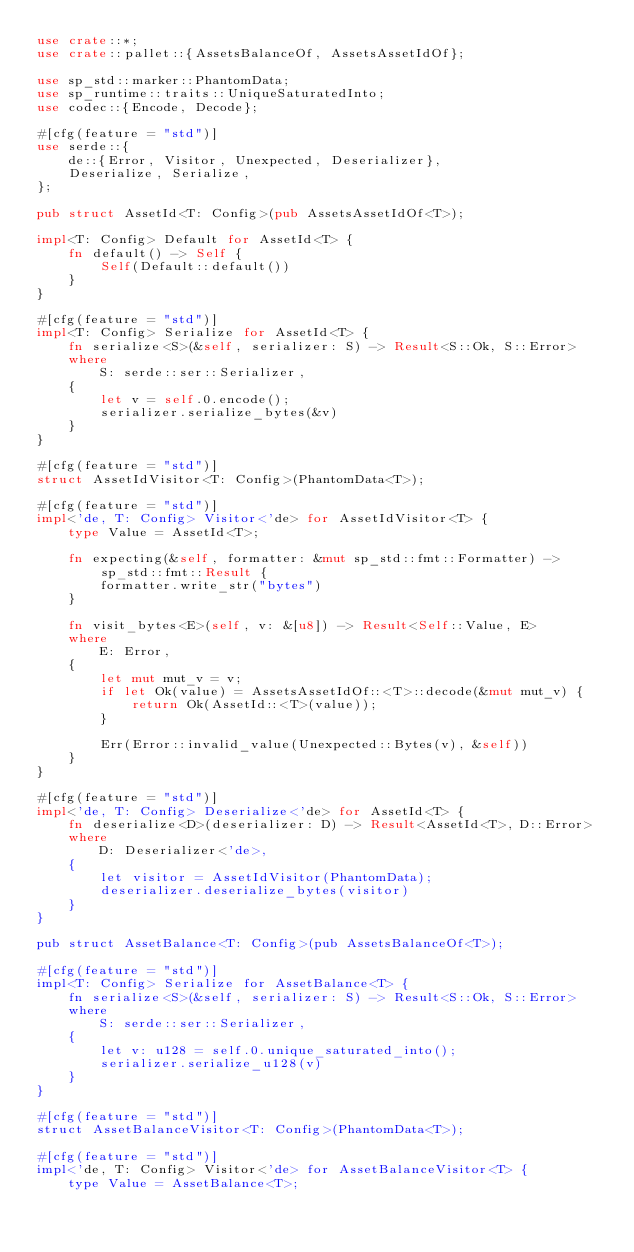<code> <loc_0><loc_0><loc_500><loc_500><_Rust_>use crate::*;
use crate::pallet::{AssetsBalanceOf, AssetsAssetIdOf};

use sp_std::marker::PhantomData;
use sp_runtime::traits::UniqueSaturatedInto;
use codec::{Encode, Decode};

#[cfg(feature = "std")]
use serde::{
    de::{Error, Visitor, Unexpected, Deserializer},
    Deserialize, Serialize,
};

pub struct AssetId<T: Config>(pub AssetsAssetIdOf<T>);

impl<T: Config> Default for AssetId<T> {
    fn default() -> Self {
        Self(Default::default())
    }
}

#[cfg(feature = "std")]
impl<T: Config> Serialize for AssetId<T> {
    fn serialize<S>(&self, serializer: S) -> Result<S::Ok, S::Error>
    where
        S: serde::ser::Serializer,
    {
        let v = self.0.encode();
        serializer.serialize_bytes(&v)
    }
}

#[cfg(feature = "std")]
struct AssetIdVisitor<T: Config>(PhantomData<T>);

#[cfg(feature = "std")]
impl<'de, T: Config> Visitor<'de> for AssetIdVisitor<T> {
    type Value = AssetId<T>;

    fn expecting(&self, formatter: &mut sp_std::fmt::Formatter) -> sp_std::fmt::Result {
        formatter.write_str("bytes")
    }

    fn visit_bytes<E>(self, v: &[u8]) -> Result<Self::Value, E>
    where
        E: Error,
    {
        let mut mut_v = v;
        if let Ok(value) = AssetsAssetIdOf::<T>::decode(&mut mut_v) {
            return Ok(AssetId::<T>(value));
        }

        Err(Error::invalid_value(Unexpected::Bytes(v), &self))
    }
}

#[cfg(feature = "std")]
impl<'de, T: Config> Deserialize<'de> for AssetId<T> {
    fn deserialize<D>(deserializer: D) -> Result<AssetId<T>, D::Error>
    where
        D: Deserializer<'de>,
    {
        let visitor = AssetIdVisitor(PhantomData);
        deserializer.deserialize_bytes(visitor)
    }
}

pub struct AssetBalance<T: Config>(pub AssetsBalanceOf<T>);

#[cfg(feature = "std")]
impl<T: Config> Serialize for AssetBalance<T> {
    fn serialize<S>(&self, serializer: S) -> Result<S::Ok, S::Error>
    where
        S: serde::ser::Serializer,
    {
        let v: u128 = self.0.unique_saturated_into();
        serializer.serialize_u128(v)
    }
}

#[cfg(feature = "std")]
struct AssetBalanceVisitor<T: Config>(PhantomData<T>);

#[cfg(feature = "std")]
impl<'de, T: Config> Visitor<'de> for AssetBalanceVisitor<T> {
    type Value = AssetBalance<T>;
</code> 